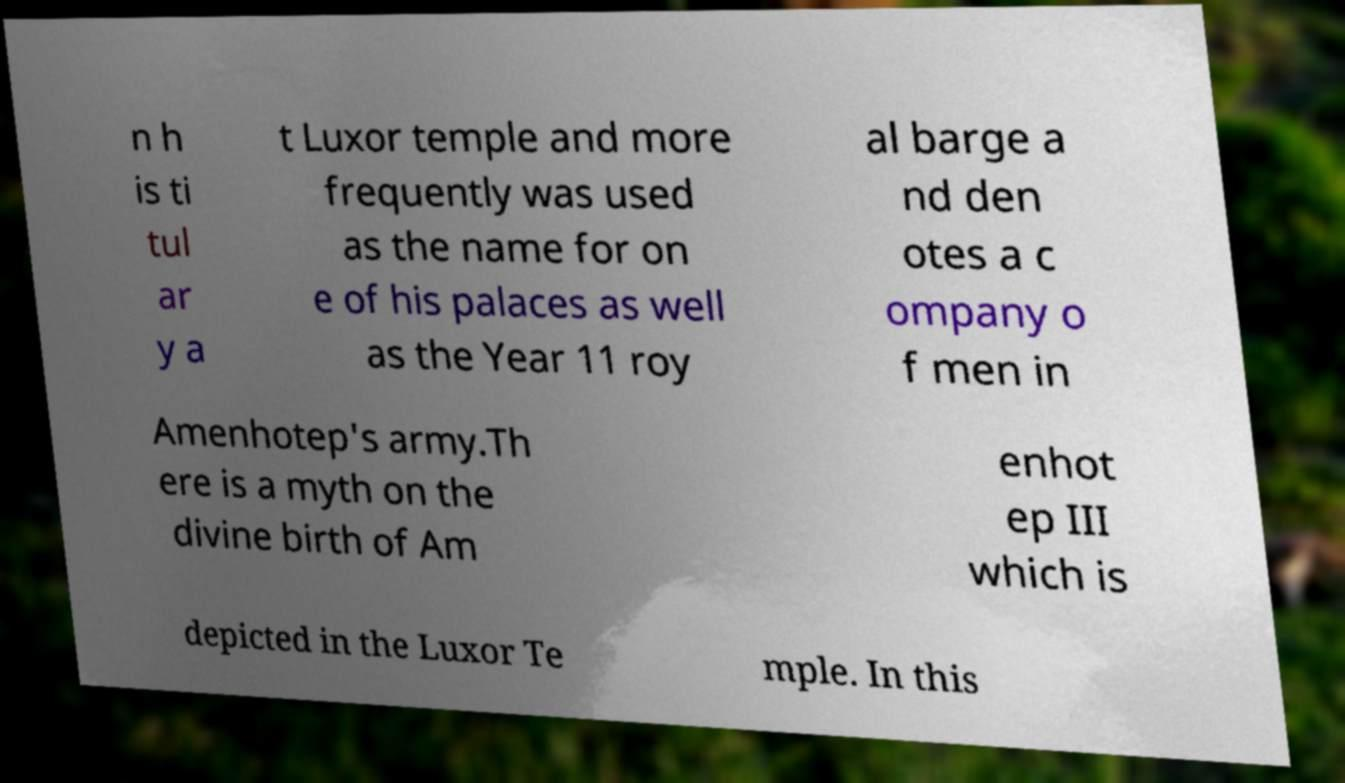Can you read and provide the text displayed in the image?This photo seems to have some interesting text. Can you extract and type it out for me? n h is ti tul ar y a t Luxor temple and more frequently was used as the name for on e of his palaces as well as the Year 11 roy al barge a nd den otes a c ompany o f men in Amenhotep's army.Th ere is a myth on the divine birth of Am enhot ep III which is depicted in the Luxor Te mple. In this 